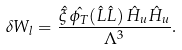Convert formula to latex. <formula><loc_0><loc_0><loc_500><loc_500>\delta W _ { l } = \frac { \hat { \xi } \, \hat { \phi _ { T } } ( \hat { L } \hat { L } ) \, \hat { H } _ { u } \hat { H } _ { u } } { \Lambda ^ { 3 } } .</formula> 